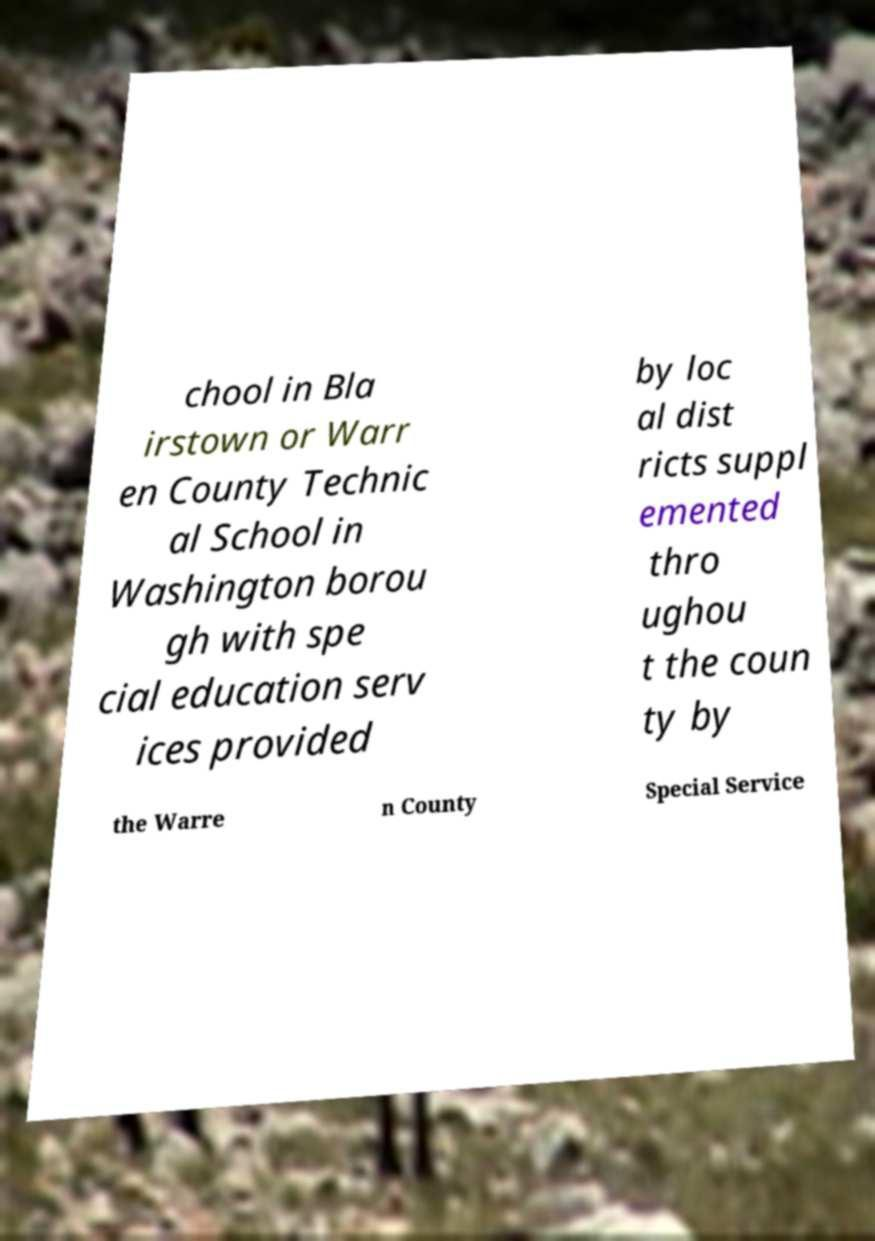Could you extract and type out the text from this image? chool in Bla irstown or Warr en County Technic al School in Washington borou gh with spe cial education serv ices provided by loc al dist ricts suppl emented thro ughou t the coun ty by the Warre n County Special Service 